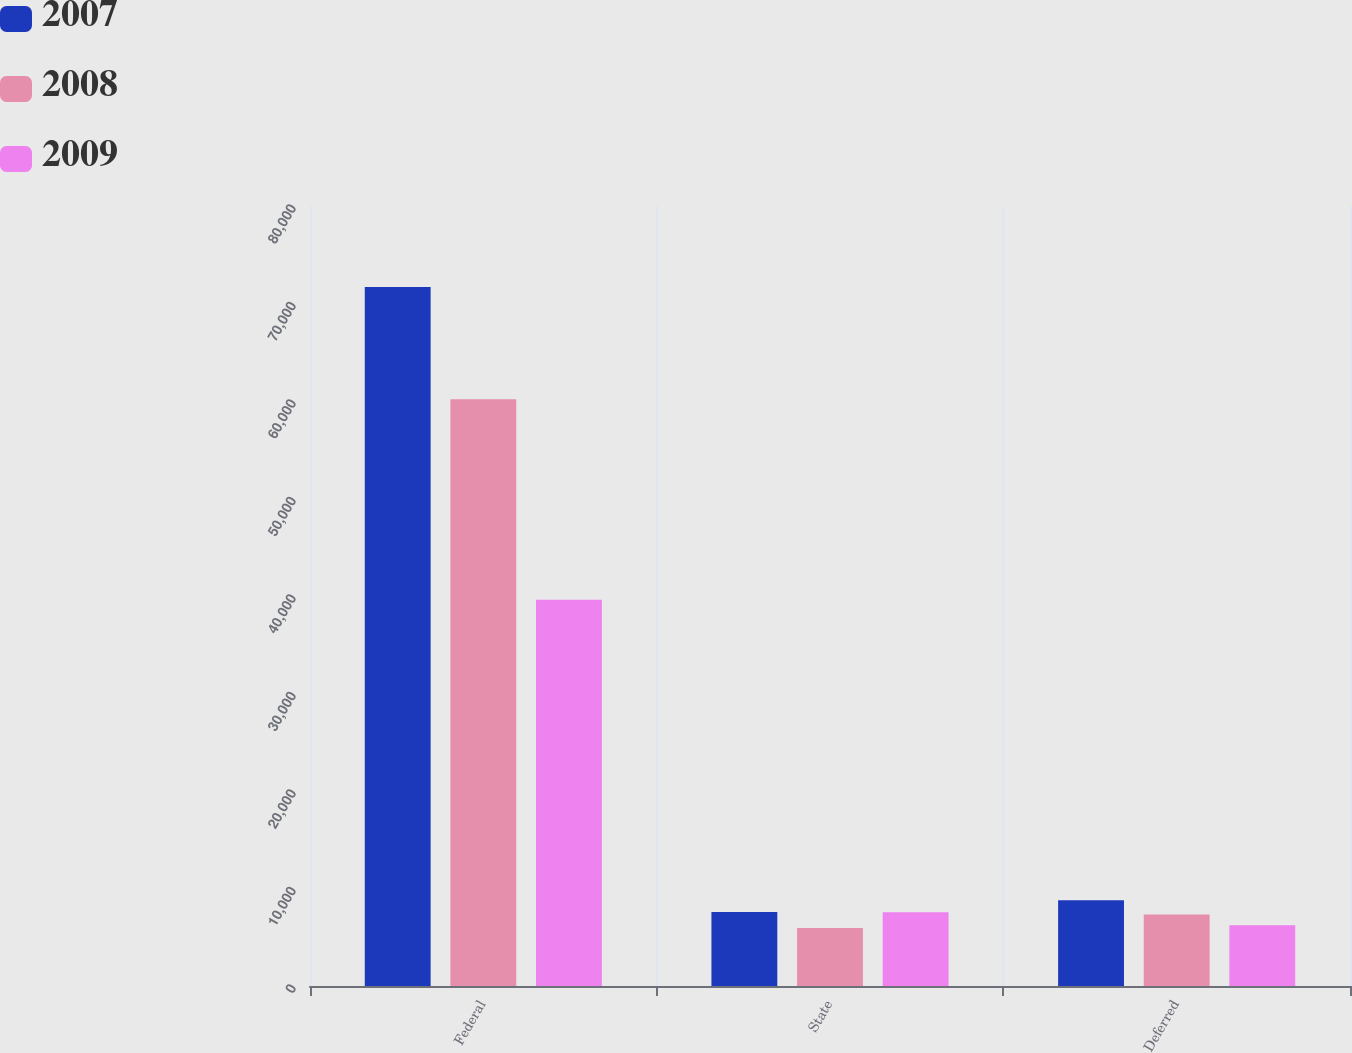<chart> <loc_0><loc_0><loc_500><loc_500><stacked_bar_chart><ecel><fcel>Federal<fcel>State<fcel>Deferred<nl><fcel>2007<fcel>71700<fcel>7600<fcel>8800<nl><fcel>2008<fcel>60190<fcel>5951<fcel>7335<nl><fcel>2009<fcel>39624<fcel>7572<fcel>6230<nl></chart> 